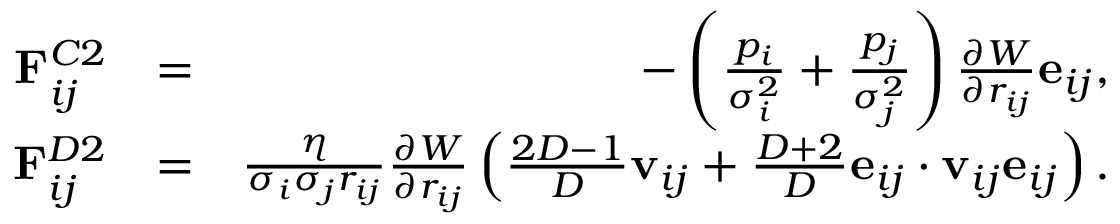Convert formula to latex. <formula><loc_0><loc_0><loc_500><loc_500>\begin{array} { r l r } { F _ { i j } ^ { C 2 } } & { = } & { - \left ( \frac { p _ { i } } { \sigma _ { i } ^ { 2 } } + \frac { p _ { j } } { \sigma _ { j } ^ { 2 } } \right ) \frac { \partial { W } } { \partial { r _ { i j } } } e _ { i j } , } \\ { F _ { i j } ^ { D 2 } } & { = } & { \frac { \eta } { \sigma _ { i } \sigma _ { j } r _ { i j } } \frac { \partial { W } } { \partial { r _ { i j } } } \left ( \frac { 2 D - 1 } { D } v _ { i j } + \frac { D + 2 } { D } e _ { i j } \cdot v _ { i j } e _ { i j } \right ) . } \end{array}</formula> 